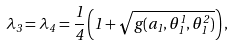Convert formula to latex. <formula><loc_0><loc_0><loc_500><loc_500>\lambda _ { 3 } = \lambda _ { 4 } = \frac { 1 } { 4 } \left ( 1 + \sqrt { g ( a _ { 1 } , \theta _ { 1 } ^ { 1 } , \theta _ { 1 } ^ { 2 } ) } \right ) ,</formula> 